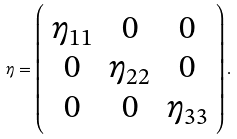<formula> <loc_0><loc_0><loc_500><loc_500>\eta = \left ( \begin{array} { c c c } { { \eta _ { 1 1 } } } & { 0 } & { 0 } \\ { 0 } & { { \eta _ { 2 2 } } } & { 0 } \\ { 0 } & { 0 } & { { \eta _ { 3 3 } } } \end{array} \right ) .</formula> 